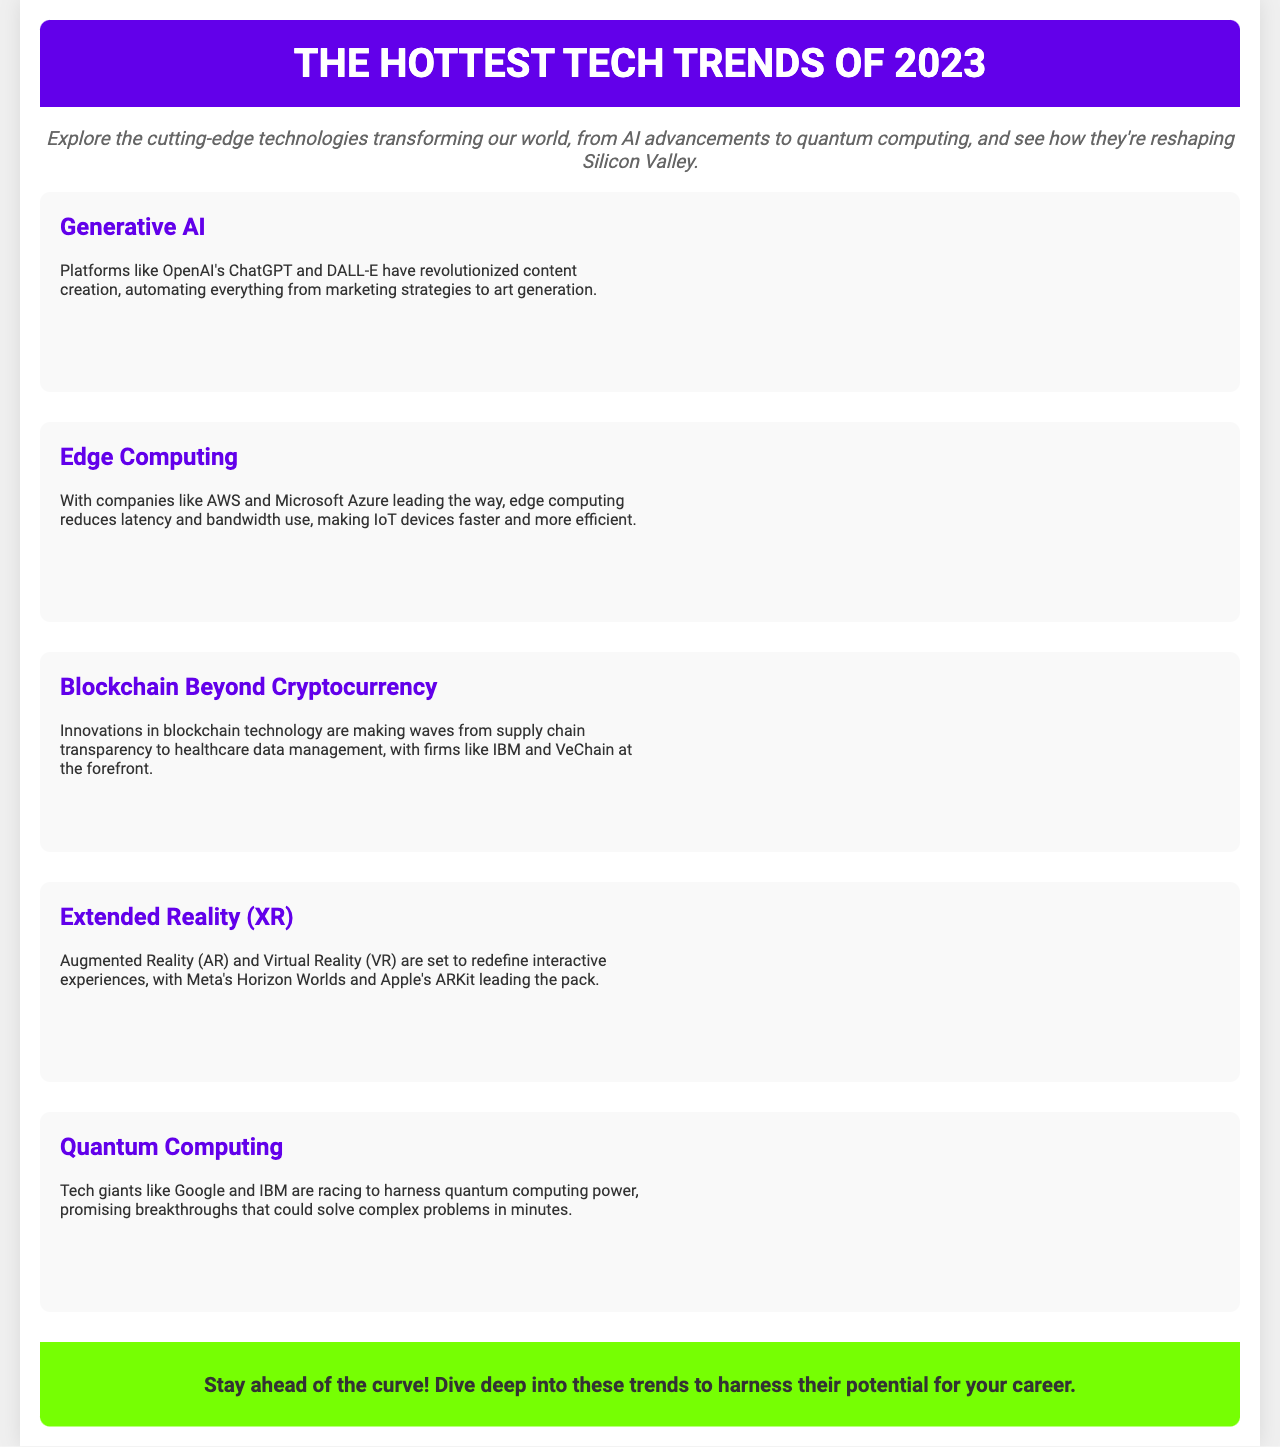What are the top tech trends of 2023? The document lists several tech trends shaping the future, specifically highlighting Generative AI, Edge Computing, Blockchain Beyond Cryptocurrency, Extended Reality (XR), and Quantum Computing.
Answer: Generative AI, Edge Computing, Blockchain Beyond Cryptocurrency, Extended Reality (XR), Quantum Computing Who are the key players in Generative AI? The document mentions OpenAI as a leading platform in the field of Generative AI, particularly with products like ChatGPT and DALL-E.
Answer: OpenAI What does Edge Computing improve? According to the content, Edge Computing reduces latency and bandwidth use, enhancing the performance of IoT devices.
Answer: Latency and bandwidth use Which company is leading in blockchain innovations? The document highlights IBM as a significant player in the innovations occurring in blockchain technology beyond cryptocurrency.
Answer: IBM What are the main applications of Extended Reality (XR)? The overview indicates that Augmented Reality (AR) and Virtual Reality (VR) redefine interactive experiences, with specific examples including Meta's Horizon Worlds and Apple's ARKit.
Answer: Augmented Reality (AR) and Virtual Reality (VR) Which tech giants are involved in Quantum Computing? The document lists Google and IBM as the major tech giants competing in the quantum computing race.
Answer: Google and IBM What is the brochure's primary purpose? The document states that it serves as an overview of emerging technologies and their impact on Silicon Valley's future, encouraging readers to stay ahead of the curve.
Answer: Overview of emerging technologies How are the visual elements presented in the document? The brochure uses eye-catching graphics alongside textual content to enhance understanding of each tech trend.
Answer: Eye-catching graphics 